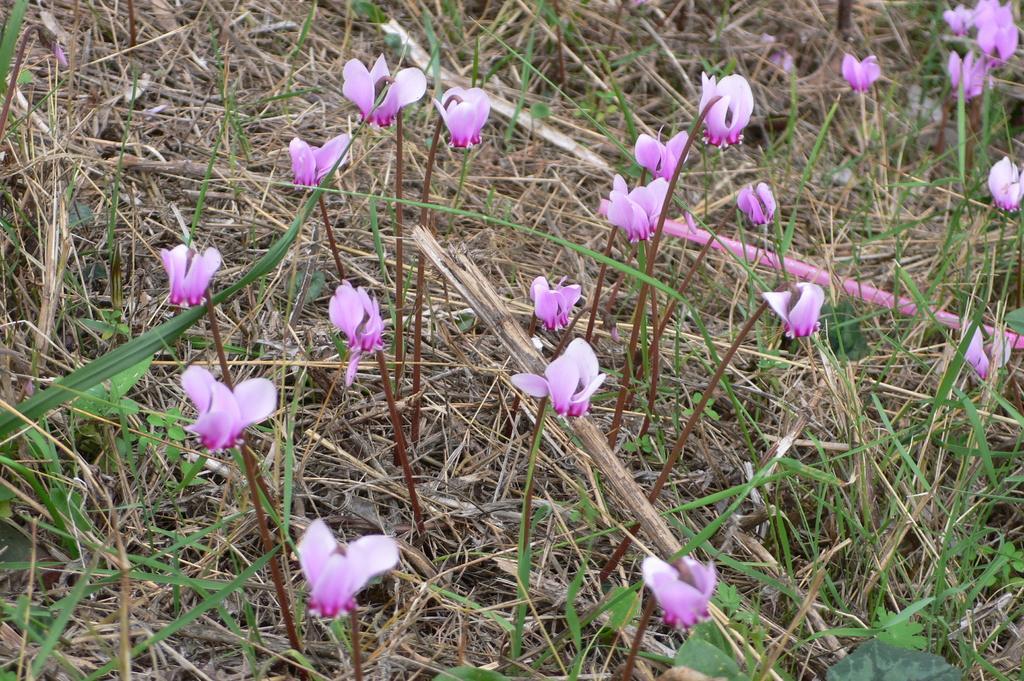Please provide a concise description of this image. In this picture there are pink color flowers on the plants. At the bottom there is green grass and there is dried grass and there are plants. 